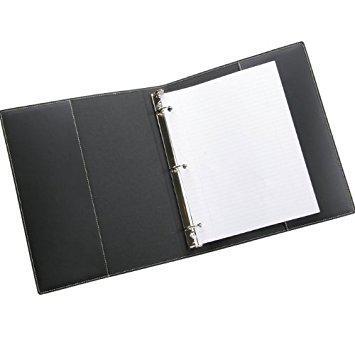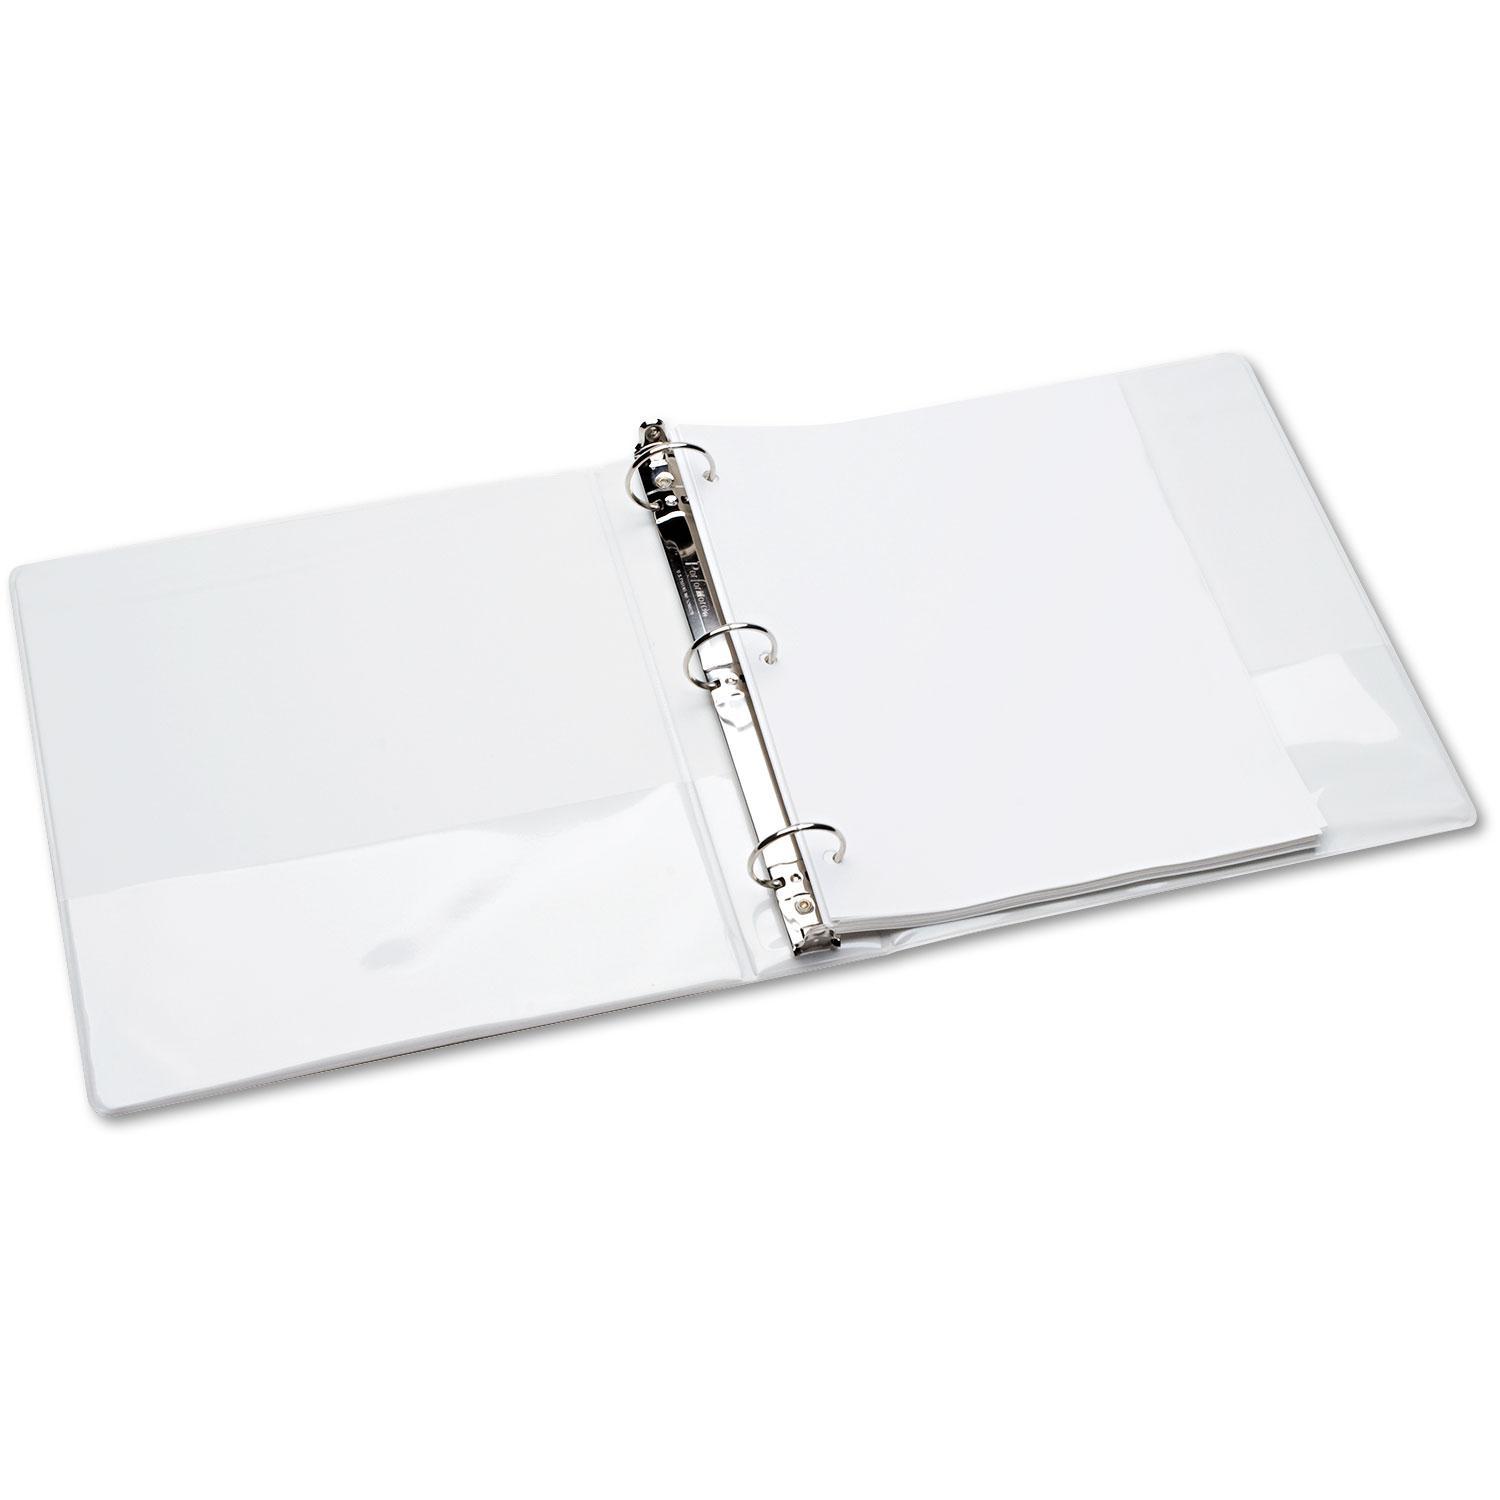The first image is the image on the left, the second image is the image on the right. For the images shown, is this caption "In one image a blue notebook is standing on end, while the other image shows more than one notebook." true? Answer yes or no. No. The first image is the image on the left, the second image is the image on the right. Analyze the images presented: Is the assertion "At least one binder is wide open." valid? Answer yes or no. Yes. 